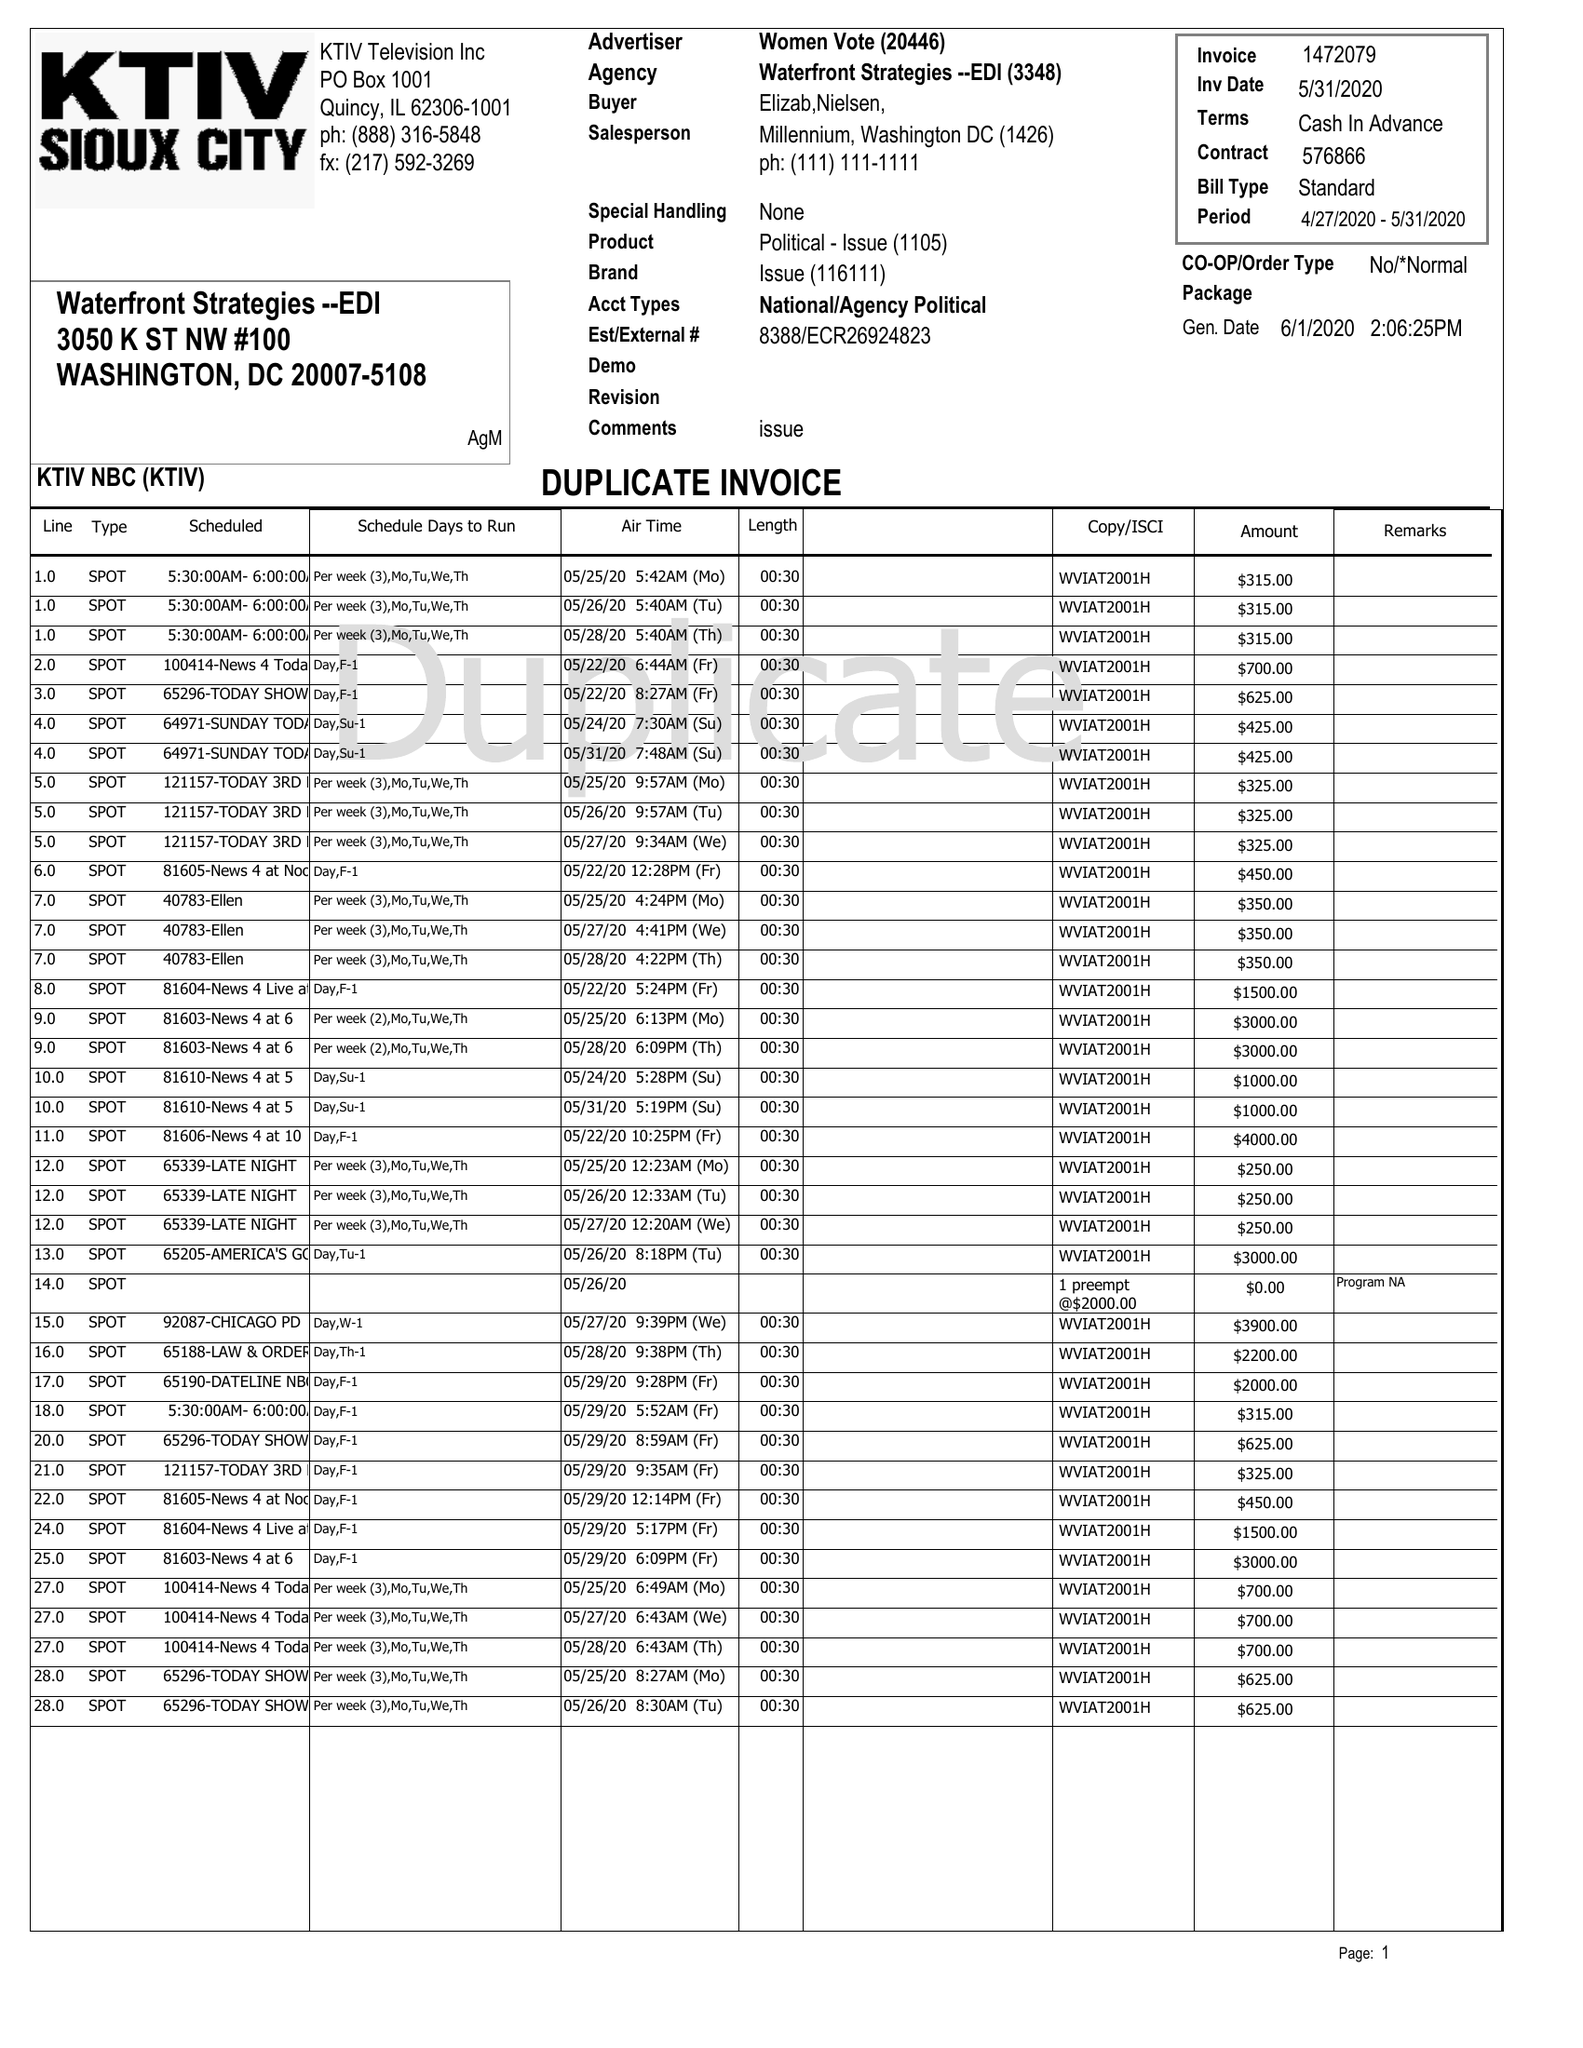What is the value for the flight_from?
Answer the question using a single word or phrase. 04/27/20 